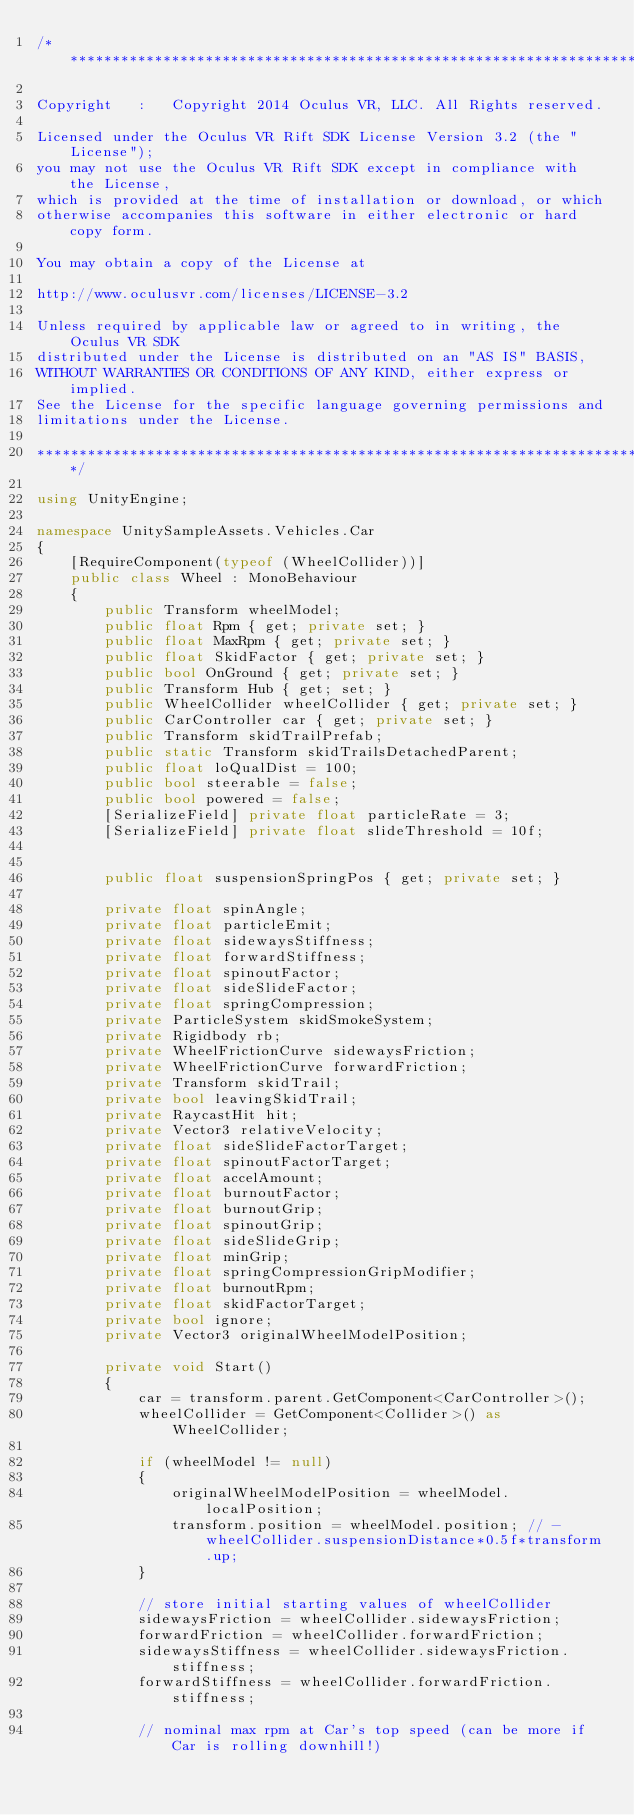Convert code to text. <code><loc_0><loc_0><loc_500><loc_500><_C#_>/************************************************************************************

Copyright   :   Copyright 2014 Oculus VR, LLC. All Rights reserved.

Licensed under the Oculus VR Rift SDK License Version 3.2 (the "License");
you may not use the Oculus VR Rift SDK except in compliance with the License,
which is provided at the time of installation or download, or which
otherwise accompanies this software in either electronic or hard copy form.

You may obtain a copy of the License at

http://www.oculusvr.com/licenses/LICENSE-3.2

Unless required by applicable law or agreed to in writing, the Oculus VR SDK
distributed under the License is distributed on an "AS IS" BASIS,
WITHOUT WARRANTIES OR CONDITIONS OF ANY KIND, either express or implied.
See the License for the specific language governing permissions and
limitations under the License.

************************************************************************************/

using UnityEngine;

namespace UnitySampleAssets.Vehicles.Car
{
    [RequireComponent(typeof (WheelCollider))]
    public class Wheel : MonoBehaviour
    {
        public Transform wheelModel;
        public float Rpm { get; private set; }
        public float MaxRpm { get; private set; }
        public float SkidFactor { get; private set; }
        public bool OnGround { get; private set; }
        public Transform Hub { get; set; }
        public WheelCollider wheelCollider { get; private set; }
        public CarController car { get; private set; }
        public Transform skidTrailPrefab;
        public static Transform skidTrailsDetachedParent;
        public float loQualDist = 100;
        public bool steerable = false;
        public bool powered = false;
        [SerializeField] private float particleRate = 3;
        [SerializeField] private float slideThreshold = 10f;


        public float suspensionSpringPos { get; private set; }

        private float spinAngle;
        private float particleEmit;
        private float sidewaysStiffness;
        private float forwardStiffness;
        private float spinoutFactor;
        private float sideSlideFactor;
        private float springCompression;
        private ParticleSystem skidSmokeSystem;
        private Rigidbody rb;
        private WheelFrictionCurve sidewaysFriction;
        private WheelFrictionCurve forwardFriction;
        private Transform skidTrail;
        private bool leavingSkidTrail;
        private RaycastHit hit;
        private Vector3 relativeVelocity;
        private float sideSlideFactorTarget;
        private float spinoutFactorTarget;
        private float accelAmount;
        private float burnoutFactor;
        private float burnoutGrip;
        private float spinoutGrip;
        private float sideSlideGrip;
        private float minGrip;
        private float springCompressionGripModifier;
        private float burnoutRpm;
        private float skidFactorTarget;
        private bool ignore;
        private Vector3 originalWheelModelPosition;

        private void Start()
        {
            car = transform.parent.GetComponent<CarController>();
            wheelCollider = GetComponent<Collider>() as WheelCollider;

            if (wheelModel != null)
            {
                originalWheelModelPosition = wheelModel.localPosition;
                transform.position = wheelModel.position; // - wheelCollider.suspensionDistance*0.5f*transform.up;
            }

            // store initial starting values of wheelCollider
            sidewaysFriction = wheelCollider.sidewaysFriction;
            forwardFriction = wheelCollider.forwardFriction;
            sidewaysStiffness = wheelCollider.sidewaysFriction.stiffness;
            forwardStiffness = wheelCollider.forwardFriction.stiffness;

            // nominal max rpm at Car's top speed (can be more if Car is rolling downhill!)</code> 